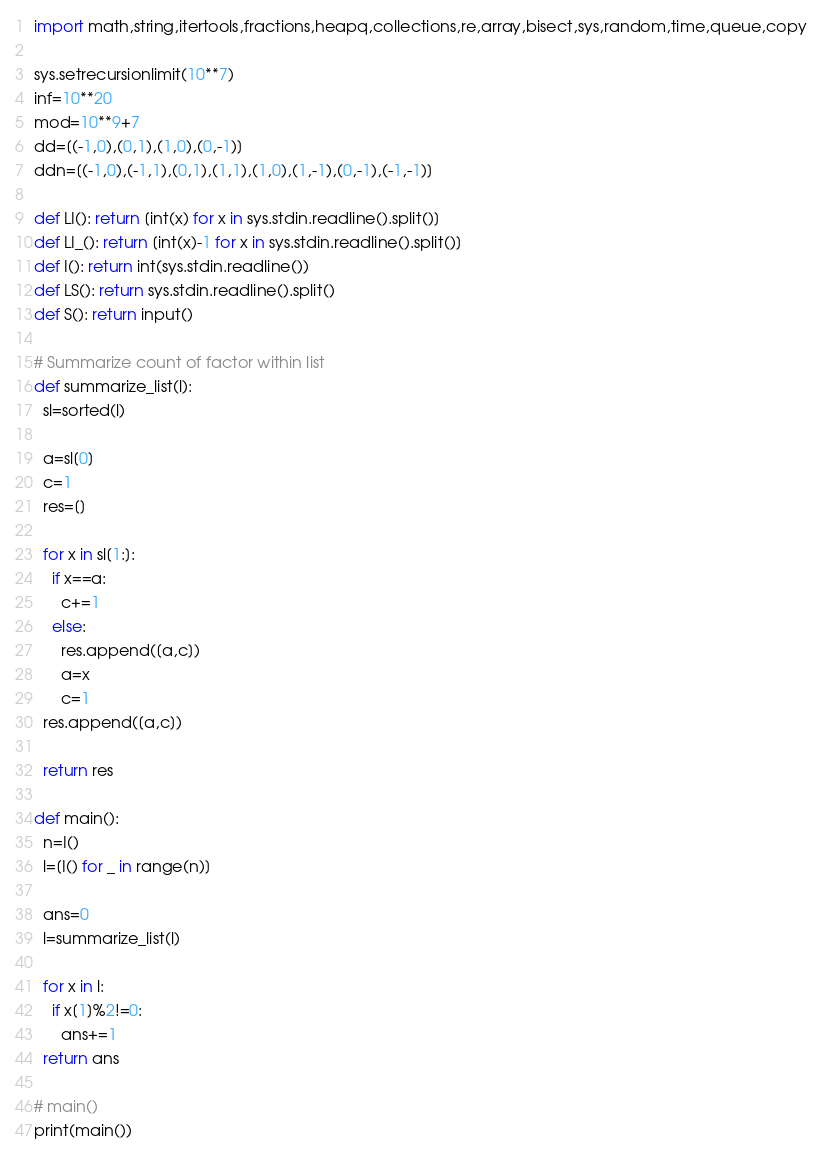<code> <loc_0><loc_0><loc_500><loc_500><_Python_>import math,string,itertools,fractions,heapq,collections,re,array,bisect,sys,random,time,queue,copy

sys.setrecursionlimit(10**7)
inf=10**20
mod=10**9+7
dd=[(-1,0),(0,1),(1,0),(0,-1)]
ddn=[(-1,0),(-1,1),(0,1),(1,1),(1,0),(1,-1),(0,-1),(-1,-1)]

def LI(): return [int(x) for x in sys.stdin.readline().split()]
def LI_(): return [int(x)-1 for x in sys.stdin.readline().split()]
def I(): return int(sys.stdin.readline())
def LS(): return sys.stdin.readline().split()
def S(): return input()

# Summarize count of factor within list
def summarize_list(l):
  sl=sorted(l)

  a=sl[0]
  c=1
  res=[]

  for x in sl[1:]:
    if x==a:
      c+=1
    else:
      res.append([a,c])
      a=x
      c=1
  res.append([a,c])

  return res

def main():
  n=I()
  l=[I() for _ in range(n)]

  ans=0
  l=summarize_list(l)

  for x in l:
    if x[1]%2!=0:
      ans+=1
  return ans

# main()
print(main())
</code> 